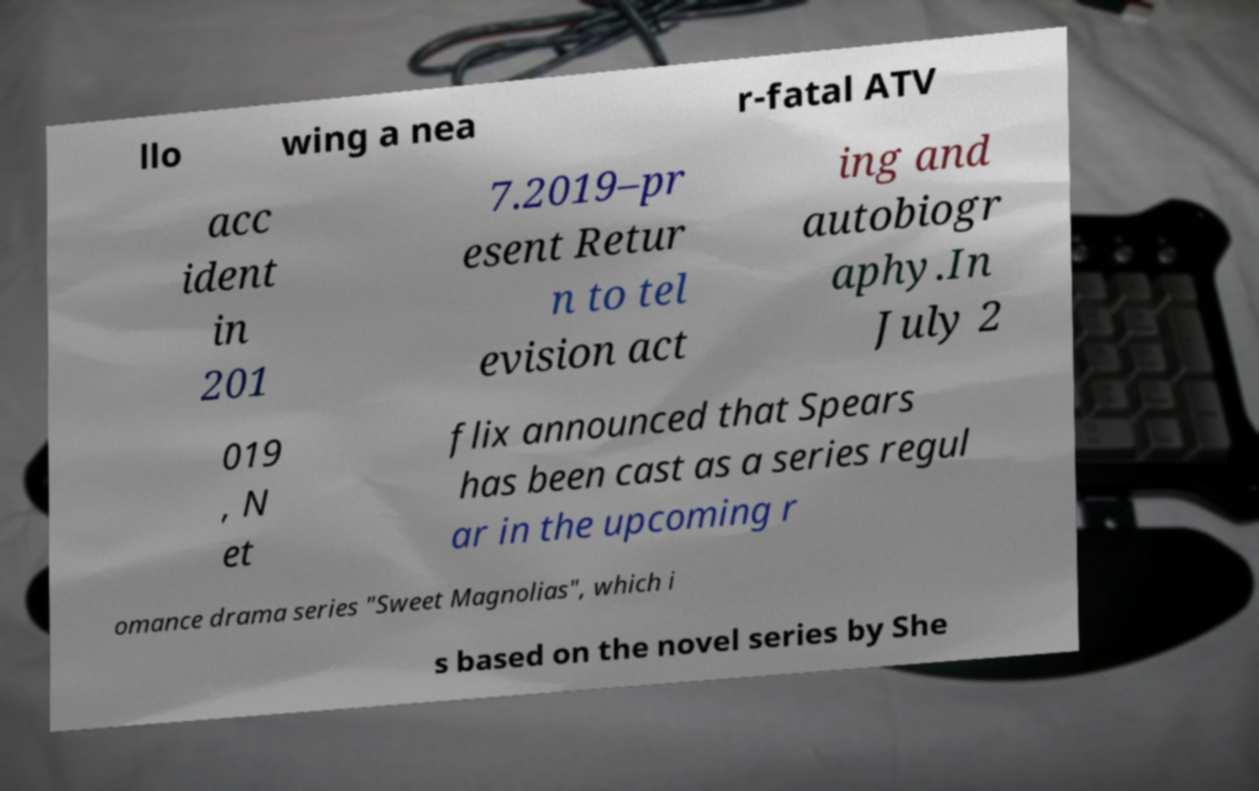Can you read and provide the text displayed in the image?This photo seems to have some interesting text. Can you extract and type it out for me? llo wing a nea r-fatal ATV acc ident in 201 7.2019–pr esent Retur n to tel evision act ing and autobiogr aphy.In July 2 019 , N et flix announced that Spears has been cast as a series regul ar in the upcoming r omance drama series "Sweet Magnolias", which i s based on the novel series by She 